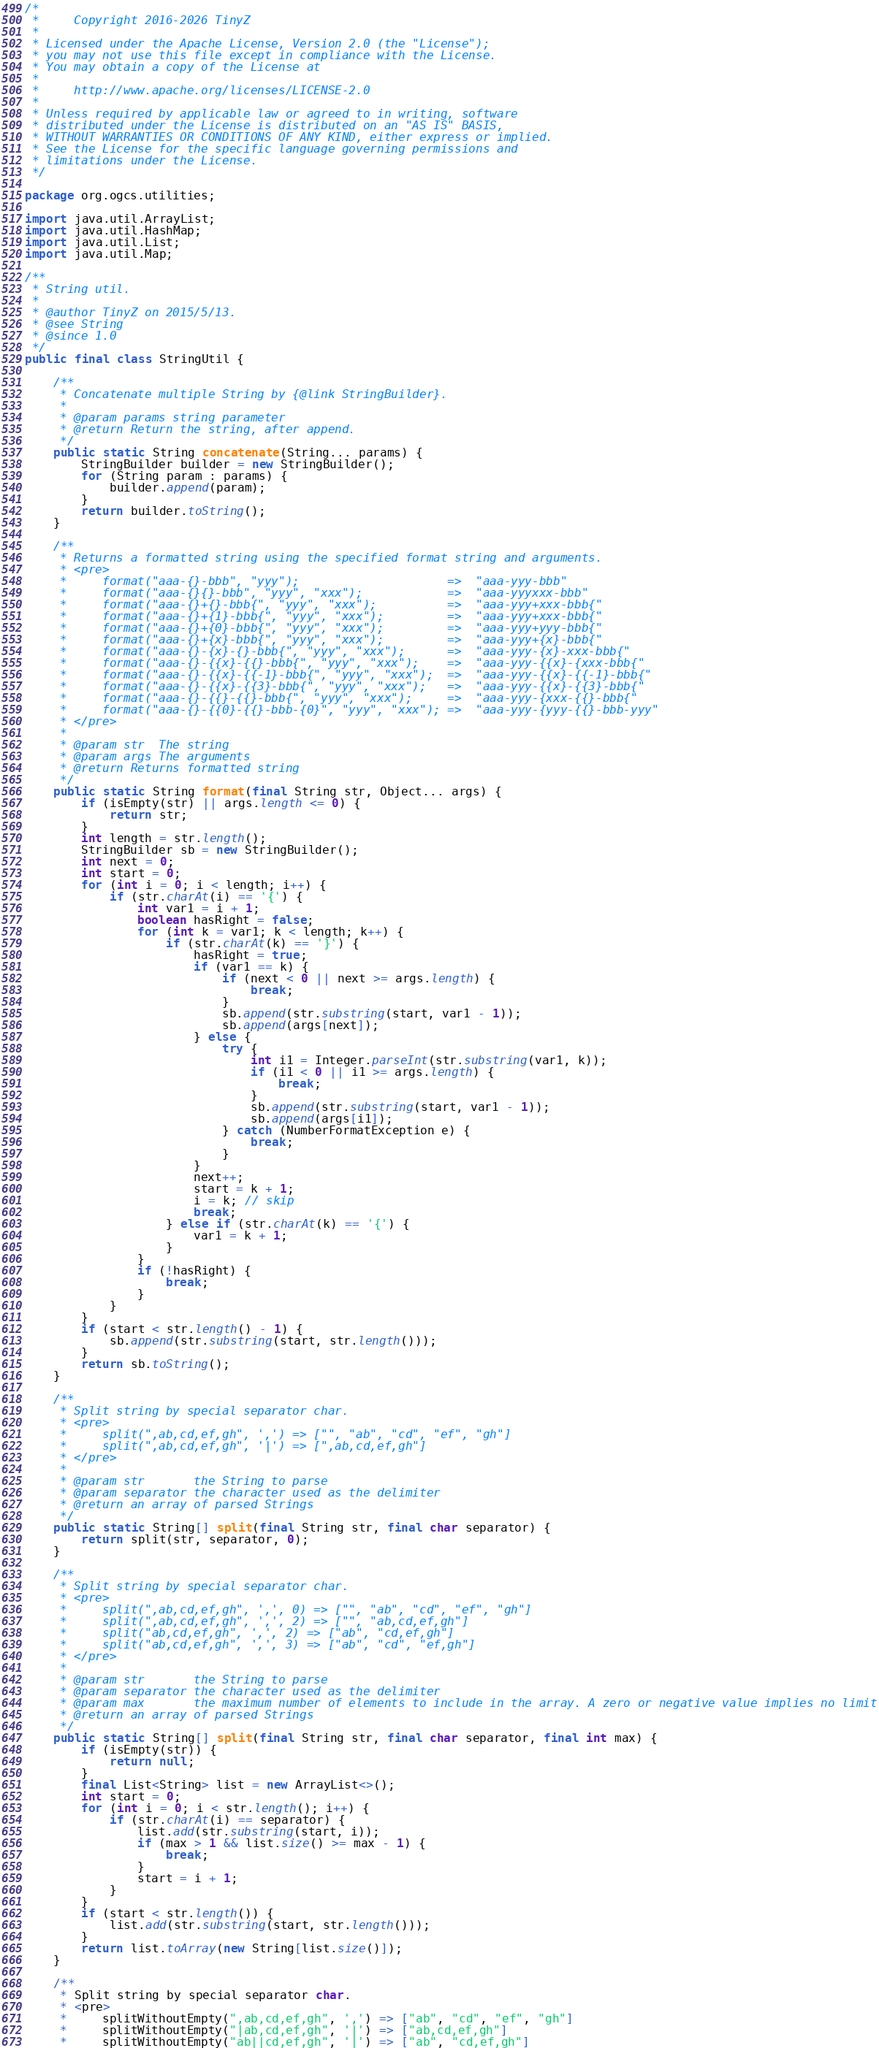<code> <loc_0><loc_0><loc_500><loc_500><_Java_>/*
 *     Copyright 2016-2026 TinyZ
 *
 * Licensed under the Apache License, Version 2.0 (the "License");
 * you may not use this file except in compliance with the License.
 * You may obtain a copy of the License at
 *
 *     http://www.apache.org/licenses/LICENSE-2.0
 *
 * Unless required by applicable law or agreed to in writing, software
 * distributed under the License is distributed on an "AS IS" BASIS,
 * WITHOUT WARRANTIES OR CONDITIONS OF ANY KIND, either express or implied.
 * See the License for the specific language governing permissions and
 * limitations under the License.
 */

package org.ogcs.utilities;

import java.util.ArrayList;
import java.util.HashMap;
import java.util.List;
import java.util.Map;

/**
 * String util.
 *
 * @author TinyZ on 2015/5/13.
 * @see String
 * @since 1.0
 */
public final class StringUtil {

    /**
     * Concatenate multiple String by {@link StringBuilder}.
     *
     * @param params string parameter
     * @return Return the string, after append.
     */
    public static String concatenate(String... params) {
        StringBuilder builder = new StringBuilder();
        for (String param : params) {
            builder.append(param);
        }
        return builder.toString();
    }

    /**
     * Returns a formatted string using the specified format string and arguments.
     * <pre>
     *     format("aaa-{}-bbb", "yyy");                     =>  "aaa-yyy-bbb"
     *     format("aaa-{}{}-bbb", "yyy", "xxx");            =>  "aaa-yyyxxx-bbb"
     *     format("aaa-{}+{}-bbb{", "yyy", "xxx");          =>  "aaa-yyy+xxx-bbb{"
     *     format("aaa-{}+{1}-bbb{", "yyy", "xxx");         =>  "aaa-yyy+xxx-bbb{"
     *     format("aaa-{}+{0}-bbb{", "yyy", "xxx");         =>  "aaa-yyy+yyy-bbb{"
     *     format("aaa-{}+{x}-bbb{", "yyy", "xxx");         =>  "aaa-yyy+{x}-bbb{"
     *     format("aaa-{}-{x}-{}-bbb{", "yyy", "xxx");      =>  "aaa-yyy-{x}-xxx-bbb{"
     *     format("aaa-{}-{{x}-{{}-bbb{", "yyy", "xxx");    =>  "aaa-yyy-{{x}-{xxx-bbb{"
     *     format("aaa-{}-{{x}-{{-1}-bbb{", "yyy", "xxx");  =>  "aaa-yyy-{{x}-{{-1}-bbb{"
     *     format("aaa-{}-{{x}-{{3}-bbb{", "yyy", "xxx");   =>  "aaa-yyy-{{x}-{{3}-bbb{"
     *     format("aaa-{}-{{}-{{}-bbb{", "yyy", "xxx");     =>  "aaa-yyy-{xxx-{{}-bbb{"
     *     format("aaa-{}-{{0}-{{}-bbb-{0}", "yyy", "xxx"); =>  "aaa-yyy-{yyy-{{}-bbb-yyy"
     * </pre>
     *
     * @param str  The string
     * @param args The arguments
     * @return Returns formatted string
     */
    public static String format(final String str, Object... args) {
        if (isEmpty(str) || args.length <= 0) {
            return str;
        }
        int length = str.length();
        StringBuilder sb = new StringBuilder();
        int next = 0;
        int start = 0;
        for (int i = 0; i < length; i++) {
            if (str.charAt(i) == '{') {
                int var1 = i + 1;
                boolean hasRight = false;
                for (int k = var1; k < length; k++) {
                    if (str.charAt(k) == '}') {
                        hasRight = true;
                        if (var1 == k) {
                            if (next < 0 || next >= args.length) {
                                break;
                            }
                            sb.append(str.substring(start, var1 - 1));
                            sb.append(args[next]);
                        } else {
                            try {
                                int i1 = Integer.parseInt(str.substring(var1, k));
                                if (i1 < 0 || i1 >= args.length) {
                                    break;
                                }
                                sb.append(str.substring(start, var1 - 1));
                                sb.append(args[i1]);
                            } catch (NumberFormatException e) {
                                break;
                            }
                        }
                        next++;
                        start = k + 1;
                        i = k; // skip
                        break;
                    } else if (str.charAt(k) == '{') {
                        var1 = k + 1;
                    }
                }
                if (!hasRight) {
                    break;
                }
            }
        }
        if (start < str.length() - 1) {
            sb.append(str.substring(start, str.length()));
        }
        return sb.toString();
    }

    /**
     * Split string by special separator char.
     * <pre>
     *     split(",ab,cd,ef,gh", ',') => ["", "ab", "cd", "ef", "gh"]
     *     split(",ab,cd,ef,gh", '|') => [",ab,cd,ef,gh"]
     * </pre>
     *
     * @param str       the String to parse
     * @param separator the character used as the delimiter
     * @return an array of parsed Strings
     */
    public static String[] split(final String str, final char separator) {
        return split(str, separator, 0);
    }

    /**
     * Split string by special separator char.
     * <pre>
     *     split(",ab,cd,ef,gh", ',', 0) => ["", "ab", "cd", "ef", "gh"]
     *     split(",ab,cd,ef,gh", ',', 2) => ["", "ab,cd,ef,gh"]
     *     split("ab,cd,ef,gh", ',', 2) => ["ab", "cd,ef,gh"]
     *     split("ab,cd,ef,gh", ',', 3) => ["ab", "cd", "ef,gh"]
     * </pre>
     *
     * @param str       the String to parse
     * @param separator the character used as the delimiter
     * @param max       the maximum number of elements to include in the array. A zero or negative value implies no limit
     * @return an array of parsed Strings
     */
    public static String[] split(final String str, final char separator, final int max) {
        if (isEmpty(str)) {
            return null;
        }
        final List<String> list = new ArrayList<>();
        int start = 0;
        for (int i = 0; i < str.length(); i++) {
            if (str.charAt(i) == separator) {
                list.add(str.substring(start, i));
                if (max > 1 && list.size() >= max - 1) {
                    break;
                }
                start = i + 1;
            }
        }
        if (start < str.length()) {
            list.add(str.substring(start, str.length()));
        }
        return list.toArray(new String[list.size()]);
    }

    /**
     * Split string by special separator char.
     * <pre>
     *     splitWithoutEmpty(",ab,cd,ef,gh", ',') => ["ab", "cd", "ef", "gh"]
     *     splitWithoutEmpty("|ab,cd,ef,gh", '|') => ["ab,cd,ef,gh"]
     *     splitWithoutEmpty("ab||cd,ef,gh", '|') => ["ab", "cd,ef,gh"]</code> 